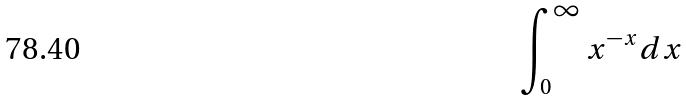Convert formula to latex. <formula><loc_0><loc_0><loc_500><loc_500>\int _ { 0 } ^ { \infty } x ^ { - x } d x</formula> 